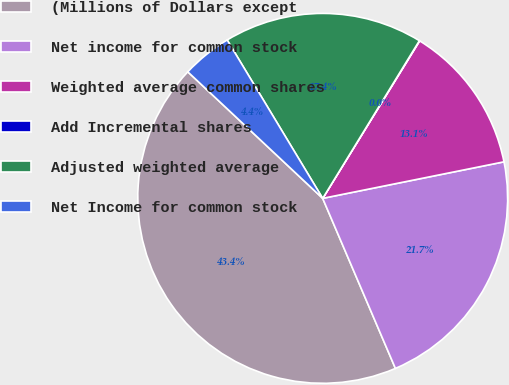Convert chart to OTSL. <chart><loc_0><loc_0><loc_500><loc_500><pie_chart><fcel>(Millions of Dollars except<fcel>Net income for common stock<fcel>Weighted average common shares<fcel>Add Incremental shares<fcel>Adjusted weighted average<fcel>Net Income for common stock<nl><fcel>43.42%<fcel>21.73%<fcel>13.05%<fcel>0.03%<fcel>17.39%<fcel>4.37%<nl></chart> 